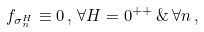Convert formula to latex. <formula><loc_0><loc_0><loc_500><loc_500>f _ { \sigma _ { n } ^ { H } } \equiv 0 \, , \, \forall H = 0 ^ { + + } \, \& \, \forall n \, ,</formula> 